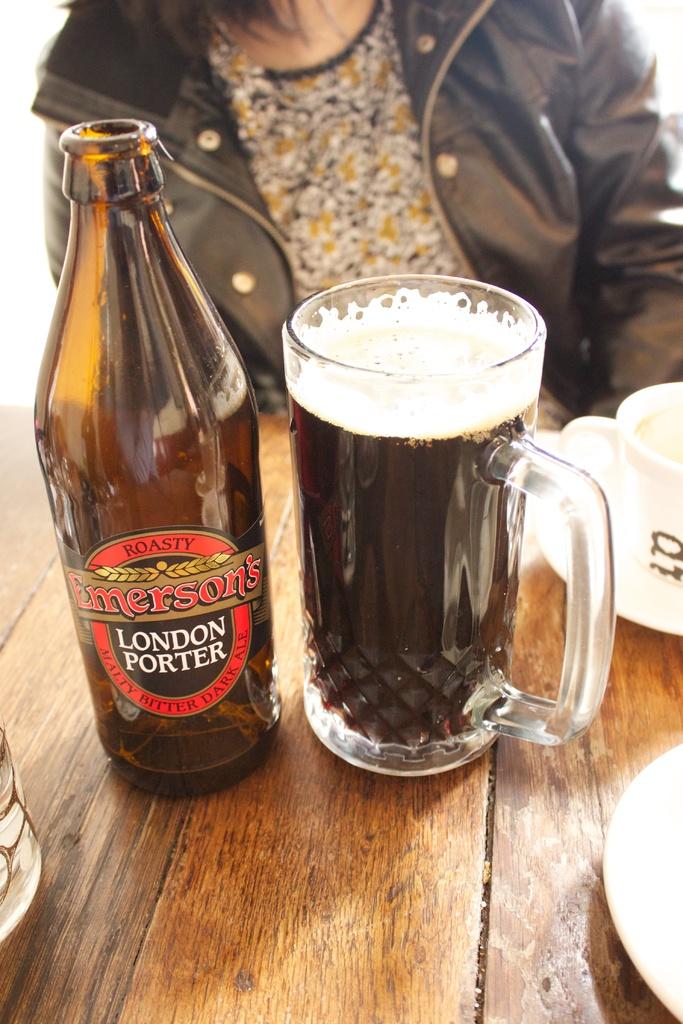What type of beer is featured in this photo?
Offer a terse response. London porter. 